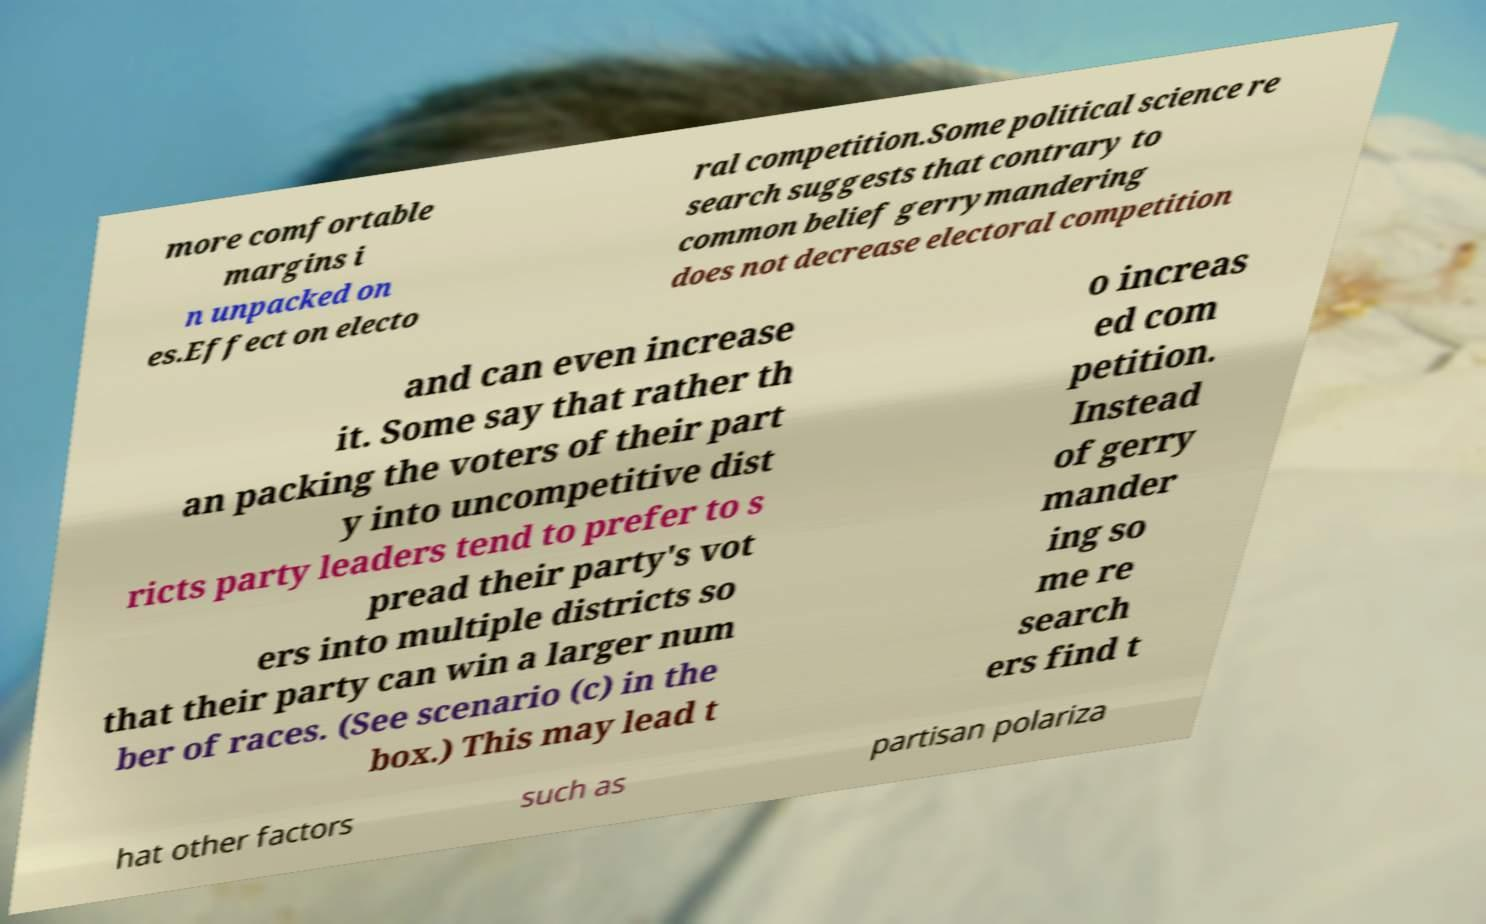There's text embedded in this image that I need extracted. Can you transcribe it verbatim? more comfortable margins i n unpacked on es.Effect on electo ral competition.Some political science re search suggests that contrary to common belief gerrymandering does not decrease electoral competition and can even increase it. Some say that rather th an packing the voters of their part y into uncompetitive dist ricts party leaders tend to prefer to s pread their party's vot ers into multiple districts so that their party can win a larger num ber of races. (See scenario (c) in the box.) This may lead t o increas ed com petition. Instead of gerry mander ing so me re search ers find t hat other factors such as partisan polariza 